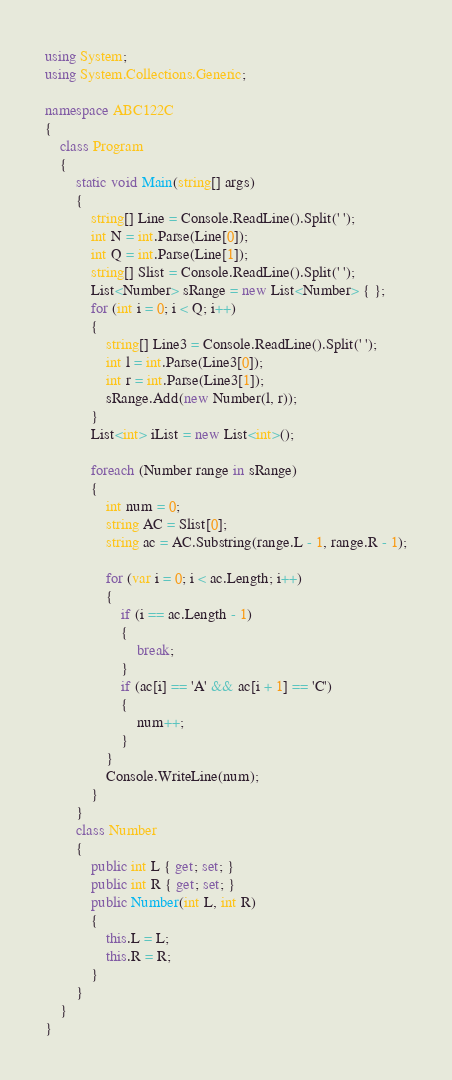Convert code to text. <code><loc_0><loc_0><loc_500><loc_500><_C#_>using System;
using System.Collections.Generic;

namespace ABC122C
{
    class Program
    {
        static void Main(string[] args)
        {
            string[] Line = Console.ReadLine().Split(' ');
            int N = int.Parse(Line[0]);
            int Q = int.Parse(Line[1]);
            string[] Slist = Console.ReadLine().Split(' ');
            List<Number> sRange = new List<Number> { };
            for (int i = 0; i < Q; i++)
            {
                string[] Line3 = Console.ReadLine().Split(' ');
                int l = int.Parse(Line3[0]);
                int r = int.Parse(Line3[1]);
                sRange.Add(new Number(l, r));
            }
            List<int> iList = new List<int>();

            foreach (Number range in sRange)
            {
                int num = 0;
                string AC = Slist[0];
                string ac = AC.Substring(range.L - 1, range.R - 1);

                for (var i = 0; i < ac.Length; i++)
                {
                    if (i == ac.Length - 1)
                    {
                        break;
                    }
                    if (ac[i] == 'A' && ac[i + 1] == 'C')
                    {
                        num++;
                    }
                }
                Console.WriteLine(num);
            }
        }
        class Number
        {
            public int L { get; set; }
            public int R { get; set; }
            public Number(int L, int R)
            {
                this.L = L;
                this.R = R;
            }
        }
    }
}
</code> 